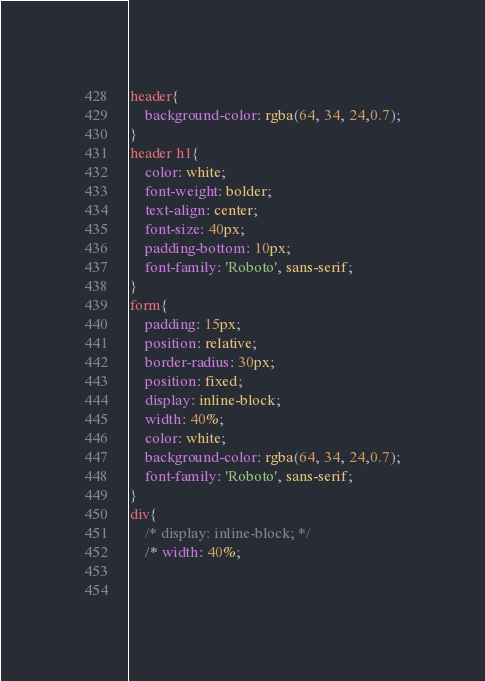<code> <loc_0><loc_0><loc_500><loc_500><_CSS_>header{
    background-color: rgba(64, 34, 24,0.7);
}
header h1{
    color: white;
    font-weight: bolder;
    text-align: center;
    font-size: 40px;
    padding-bottom: 10px;
    font-family: 'Roboto', sans-serif;
}
form{
    padding: 15px;
    position: relative;
    border-radius: 30px;
    position: fixed;
    display: inline-block;
    width: 40%;
    color: white;
    background-color: rgba(64, 34, 24,0.7);
    font-family: 'Roboto', sans-serif;
}
div{
    /* display: inline-block; */
    /* width: 40%;
    
    </code> 